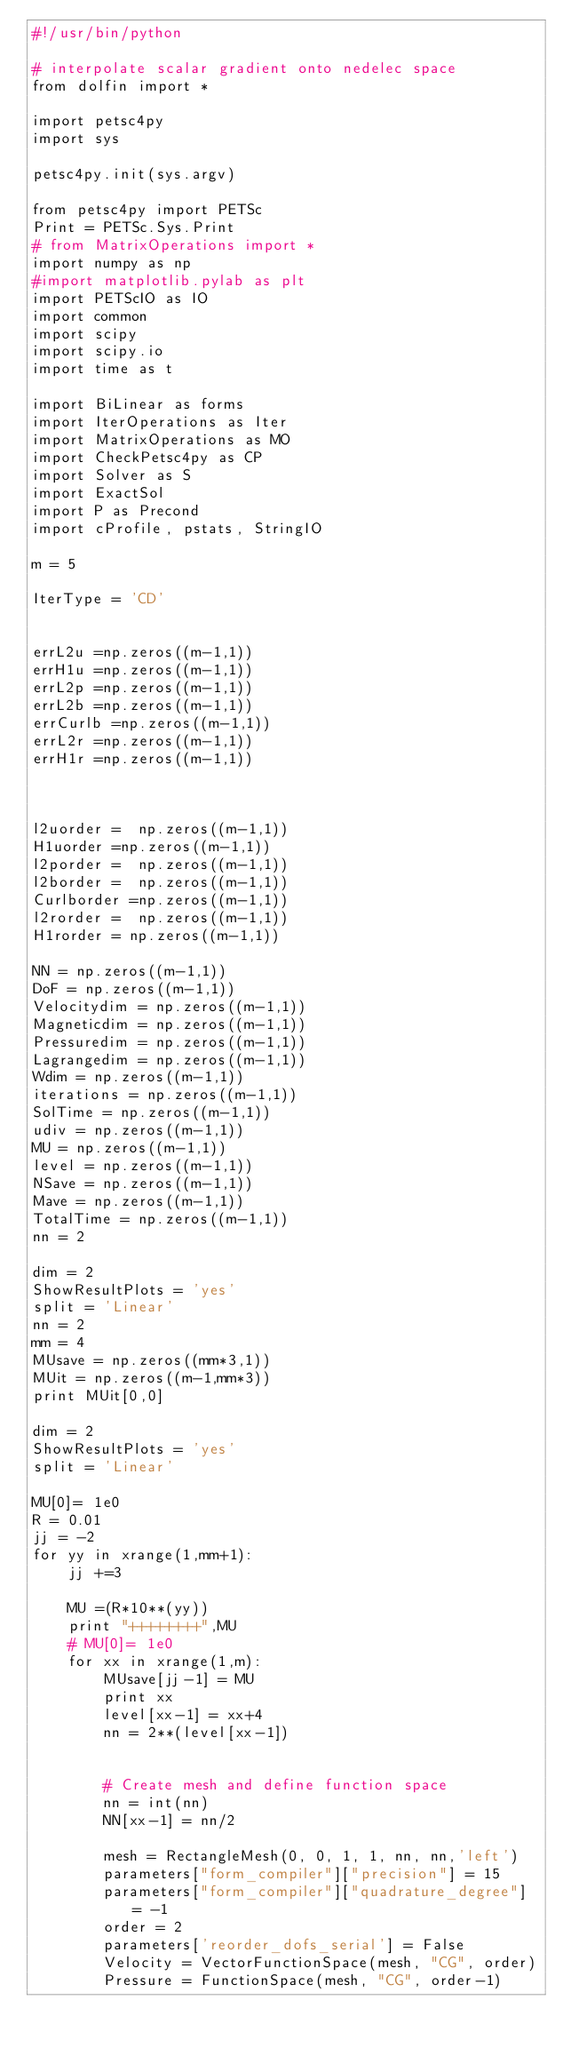<code> <loc_0><loc_0><loc_500><loc_500><_Python_>#!/usr/bin/python

# interpolate scalar gradient onto nedelec space
from dolfin import *

import petsc4py
import sys

petsc4py.init(sys.argv)

from petsc4py import PETSc
Print = PETSc.Sys.Print
# from MatrixOperations import *
import numpy as np
#import matplotlib.pylab as plt
import PETScIO as IO
import common
import scipy
import scipy.io
import time as t

import BiLinear as forms
import IterOperations as Iter
import MatrixOperations as MO
import CheckPetsc4py as CP
import Solver as S
import ExactSol
import P as Precond
import cProfile, pstats, StringIO

m = 5

IterType = 'CD'


errL2u =np.zeros((m-1,1))
errH1u =np.zeros((m-1,1))
errL2p =np.zeros((m-1,1))
errL2b =np.zeros((m-1,1))
errCurlb =np.zeros((m-1,1))
errL2r =np.zeros((m-1,1))
errH1r =np.zeros((m-1,1))



l2uorder =  np.zeros((m-1,1))
H1uorder =np.zeros((m-1,1))
l2porder =  np.zeros((m-1,1))
l2border =  np.zeros((m-1,1))
Curlborder =np.zeros((m-1,1))
l2rorder =  np.zeros((m-1,1))
H1rorder = np.zeros((m-1,1))

NN = np.zeros((m-1,1))
DoF = np.zeros((m-1,1))
Velocitydim = np.zeros((m-1,1))
Magneticdim = np.zeros((m-1,1))
Pressuredim = np.zeros((m-1,1))
Lagrangedim = np.zeros((m-1,1))
Wdim = np.zeros((m-1,1))
iterations = np.zeros((m-1,1))
SolTime = np.zeros((m-1,1))
udiv = np.zeros((m-1,1))
MU = np.zeros((m-1,1))
level = np.zeros((m-1,1))
NSave = np.zeros((m-1,1))
Mave = np.zeros((m-1,1))
TotalTime = np.zeros((m-1,1))
nn = 2

dim = 2
ShowResultPlots = 'yes'
split = 'Linear'
nn = 2
mm = 4
MUsave = np.zeros((mm*3,1))
MUit = np.zeros((m-1,mm*3))
print MUit[0,0]

dim = 2
ShowResultPlots = 'yes'
split = 'Linear'

MU[0]= 1e0
R = 0.01
jj = -2
for yy in xrange(1,mm+1):
    jj +=3

    MU =(R*10**(yy))
    print "++++++++",MU
    # MU[0]= 1e0
    for xx in xrange(1,m):
        MUsave[jj-1] = MU
        print xx
        level[xx-1] = xx+4
        nn = 2**(level[xx-1])


        # Create mesh and define function space
        nn = int(nn)
        NN[xx-1] = nn/2

        mesh = RectangleMesh(0, 0, 1, 1, nn, nn,'left')
        parameters["form_compiler"]["precision"] = 15
        parameters["form_compiler"]["quadrature_degree"] = -1
        order = 2
        parameters['reorder_dofs_serial'] = False
        Velocity = VectorFunctionSpace(mesh, "CG", order)
        Pressure = FunctionSpace(mesh, "CG", order-1)</code> 